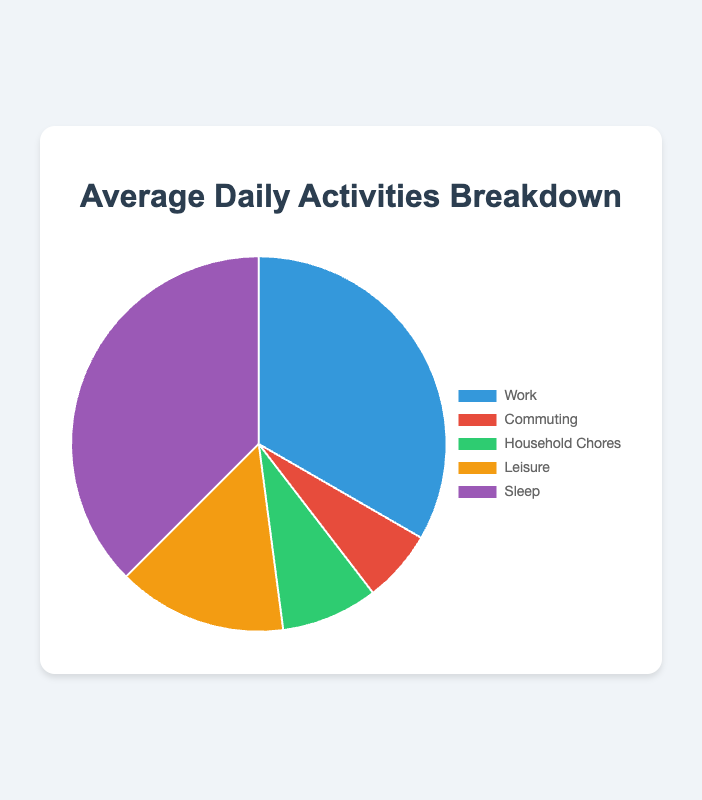What percentage of the day is spent on leisure activities? Leisure activities take 3.5 hours. To find the percentage: (3.5 / 24) * 100 = 14.58%.
Answer: 14.6% Which activity takes up the most time during the day? By looking at the pie chart, it is clear that 'Sleep' occupies the largest segment.
Answer: Sleep How much longer is the time spent sleeping compared to time spent working? Time spent sleeping is 9 hours, and time spent working is 8 hours. The difference is 9 - 8 = 1 hour.
Answer: 1 hour What is the total time spent on work and commuting combined? Time spent on work is 8 hours, and commuting is 1.5 hours. Total time is 8 + 1.5 = 9.5 hours.
Answer: 9.5 hours If you want to spend an equal amount of time on leisure and household chores, how much additional time should be added to household chores? Time spent on leisure is 3.5 hours, and household chores is 2 hours. The additional time required is 3.5 - 2 = 1.5 hours.
Answer: 1.5 hours Which two activities combined make up the smallest segment of the pie chart? The smallest segments are commuting (1.5 hours) and household chores (2 hours). Together, they are 1.5 + 2 = 3.5 hours.
Answer: Commuting and Household Chores How much less time do you spend on commuting compared to household chores? Time spent on commuting is 1.5 hours, and household chores is 2 hours. The difference is 2 - 1.5 = 0.5 hours.
Answer: 0.5 hours What fraction of the day is spent working and sleeping combined? Provide your answer as a simplified fraction. Combined hours for working and sleeping is 8 + 9 = 17 hours. To find the fraction: 17 / 24. The simplified fraction is 17/24.
Answer: 17/24 If you reduce leisure time by 1 hour, what will be the new percentage of leisure time? New leisure time is 3.5 - 1 = 2.5 hours. To find the new percentage: (2.5 / 24) * 100 = 10.42%.
Answer: 10.4% How many hours altogether are allocated to household chores and commuting? Household chores take 2 hours and commuting takes 1.5 hours. Total time is 2 + 1.5 = 3.5 hours.
Answer: 3.5 hours 